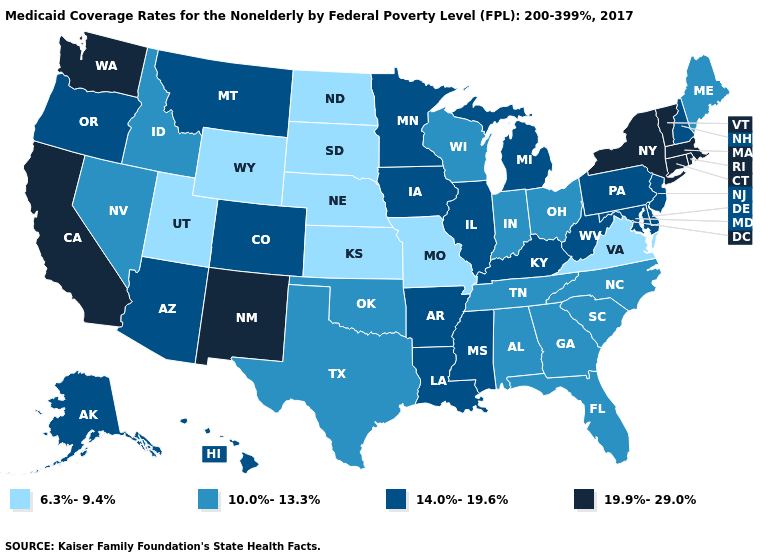Among the states that border Arizona , which have the lowest value?
Quick response, please. Utah. Name the states that have a value in the range 14.0%-19.6%?
Keep it brief. Alaska, Arizona, Arkansas, Colorado, Delaware, Hawaii, Illinois, Iowa, Kentucky, Louisiana, Maryland, Michigan, Minnesota, Mississippi, Montana, New Hampshire, New Jersey, Oregon, Pennsylvania, West Virginia. Name the states that have a value in the range 6.3%-9.4%?
Answer briefly. Kansas, Missouri, Nebraska, North Dakota, South Dakota, Utah, Virginia, Wyoming. Does Arkansas have the lowest value in the South?
Keep it brief. No. Does Delaware have the lowest value in the South?
Short answer required. No. What is the value of New York?
Short answer required. 19.9%-29.0%. What is the lowest value in the USA?
Short answer required. 6.3%-9.4%. What is the lowest value in states that border Kansas?
Quick response, please. 6.3%-9.4%. Name the states that have a value in the range 14.0%-19.6%?
Give a very brief answer. Alaska, Arizona, Arkansas, Colorado, Delaware, Hawaii, Illinois, Iowa, Kentucky, Louisiana, Maryland, Michigan, Minnesota, Mississippi, Montana, New Hampshire, New Jersey, Oregon, Pennsylvania, West Virginia. Does the first symbol in the legend represent the smallest category?
Be succinct. Yes. What is the value of Washington?
Write a very short answer. 19.9%-29.0%. What is the lowest value in states that border Mississippi?
Write a very short answer. 10.0%-13.3%. Does Washington have the lowest value in the West?
Concise answer only. No. What is the value of New Mexico?
Concise answer only. 19.9%-29.0%. Does Indiana have a higher value than Wisconsin?
Concise answer only. No. 